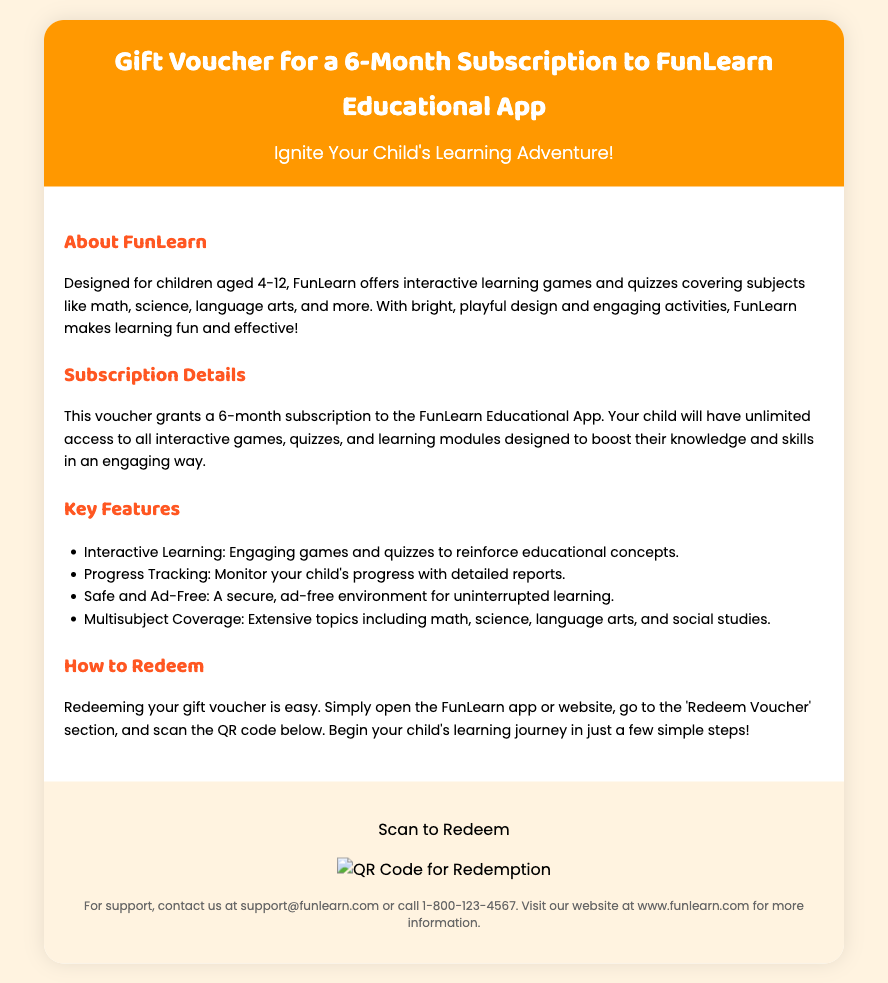what is the duration of the subscription? The document states that the voucher is for a 6-month subscription.
Answer: 6-month what age group is FunLearn designed for? The document indicates that FunLearn is designed for children aged 4-12.
Answer: 4-12 what types of subjects does FunLearn cover? The document lists subjects such as math, science, language arts, and more.
Answer: Math, science, language arts, and more how can the voucher be redeemed? The document explains that the voucher can be redeemed by scanning the QR code.
Answer: Scan the QR code what is one key feature of the FunLearn app? The document mentions that one key feature is "Interactive Learning."
Answer: Interactive Learning what kind of environment does FunLearn provide? According to the document, FunLearn provides a "secure, ad-free environment."
Answer: Ad-free what action should be taken to start learning? The document suggests scanning the QR code to begin the child's learning journey.
Answer: Scan the QR code what type of document is this? The document is specifically a gift voucher intended for educational content.
Answer: Gift voucher how can you contact support for FunLearn? The document provides contact information stating that support can be reached at an email and phone number.
Answer: support@funlearn.com or call 1-800-123-4567 